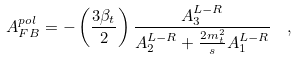Convert formula to latex. <formula><loc_0><loc_0><loc_500><loc_500>A _ { F B } ^ { p o l } = - \left ( { \frac { 3 \beta _ { t } } { 2 } } \right ) { \frac { A _ { 3 } ^ { L - R } } { A _ { 2 } ^ { L - R } + { \frac { 2 m _ { t } ^ { 2 } } { s } } A _ { 1 } ^ { L - R } } } \ \ ,</formula> 